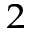<formula> <loc_0><loc_0><loc_500><loc_500>_ { 2 }</formula> 